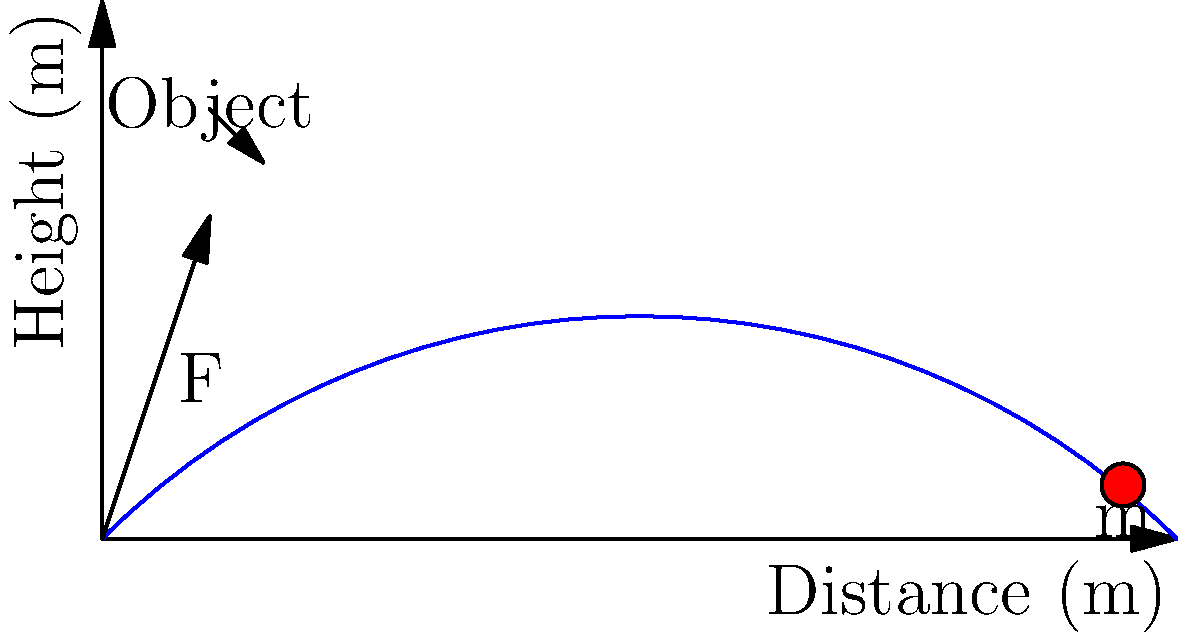In a hurling competition, you need to throw a sliotar (hurling ball) weighing 120 grams a distance of 100 meters. Assuming an initial launch angle of 45 degrees and an air resistance coefficient of 0.1 kg/m, calculate the initial force required to achieve this distance. (Use g = 9.8 m/s²) To solve this problem, we'll use the projectile motion equations and account for air resistance. Let's break it down step-by-step:

1) First, we need to determine the initial velocity required to reach 100 meters. The range equation for a projectile with air resistance is:

   $$ R = \frac{v_0^2}{g} \sin(2\theta) \left(1 - \frac{v_0^2}{2gh}\right) $$

   Where R is the range, $v_0$ is initial velocity, g is gravity, θ is launch angle, and h is the maximum height.

2) For a 45-degree angle, $\sin(2\theta) = 1$. We can estimate h as $\frac{v_0^2}{2g}$. Substituting these into the equation:

   $$ 100 = \frac{v_0^2}{9.8} \left(1 - \frac{1}{4}\right) = \frac{3v_0^2}{4(9.8)} $$

3) Solving for $v_0$:

   $$ v_0 = \sqrt{\frac{4(9.8)(100)}{3}} \approx 36.2 \text{ m/s} $$

4) Now, we need to calculate the force required to achieve this velocity. The force equation with air resistance is:

   $$ F = ma + bv^2 $$

   Where m is mass, a is acceleration, b is the air resistance coefficient, and v is velocity.

5) To find acceleration, we can use $v = at$ (assuming constant acceleration over a short time). Let's assume t = 0.1 s for the throw:

   $$ a = \frac{v}{t} = \frac{36.2}{0.1} = 362 \text{ m/s}^2 $$

6) Now we can calculate the force:

   $$ F = (0.12)(362) + (0.1)(36.2)^2 $$
   $$ F = 43.44 + 131.04 = 174.48 \text{ N} $$

Therefore, the initial force required is approximately 174.5 N.
Answer: 174.5 N 